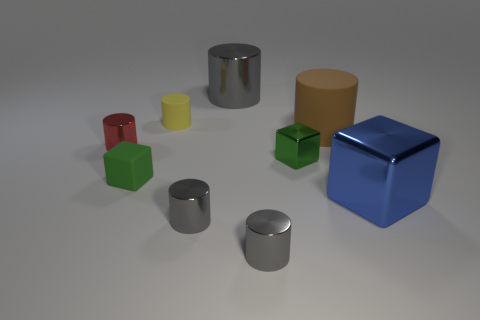Subtract all gray cylinders. How many were subtracted if there are1gray cylinders left? 2 Subtract all tiny matte cubes. How many cubes are left? 2 Add 1 red things. How many objects exist? 10 Subtract 2 cylinders. How many cylinders are left? 4 Subtract all cylinders. How many objects are left? 3 Add 4 tiny green things. How many tiny green things are left? 6 Add 7 small blue balls. How many small blue balls exist? 7 Subtract all green cubes. How many cubes are left? 1 Subtract 0 yellow balls. How many objects are left? 9 Subtract all red blocks. Subtract all cyan spheres. How many blocks are left? 3 